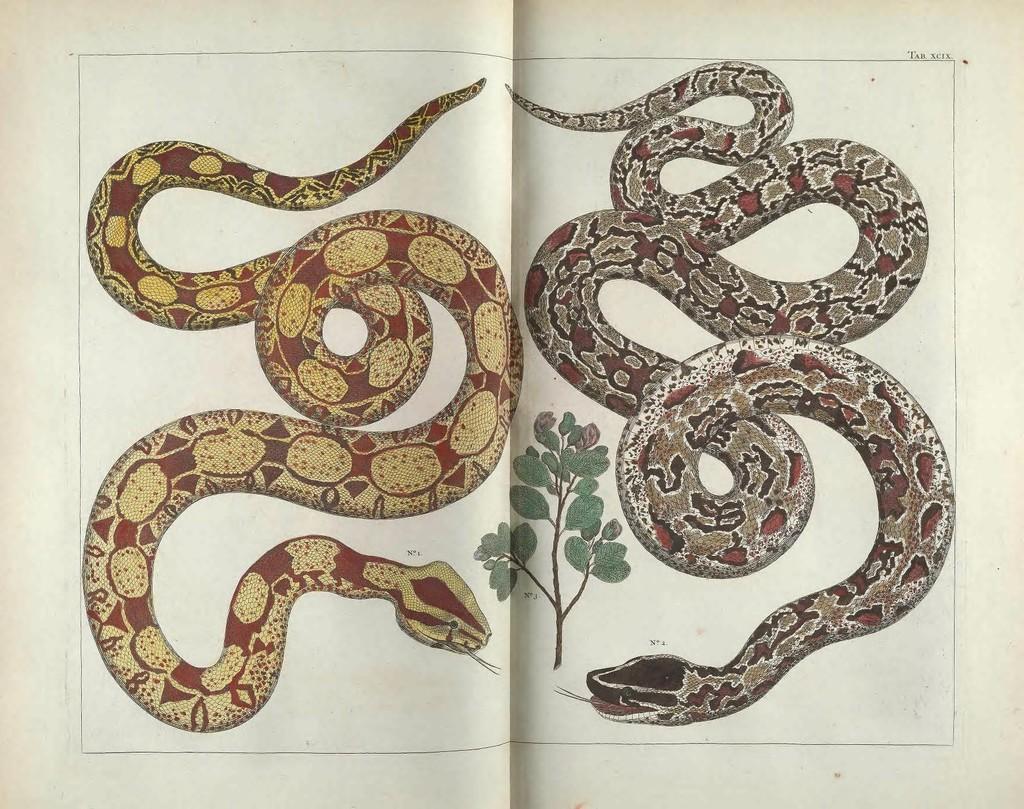Please provide a concise description of this image. In this image we can see paintings of two snakes and a plant in a paper. 